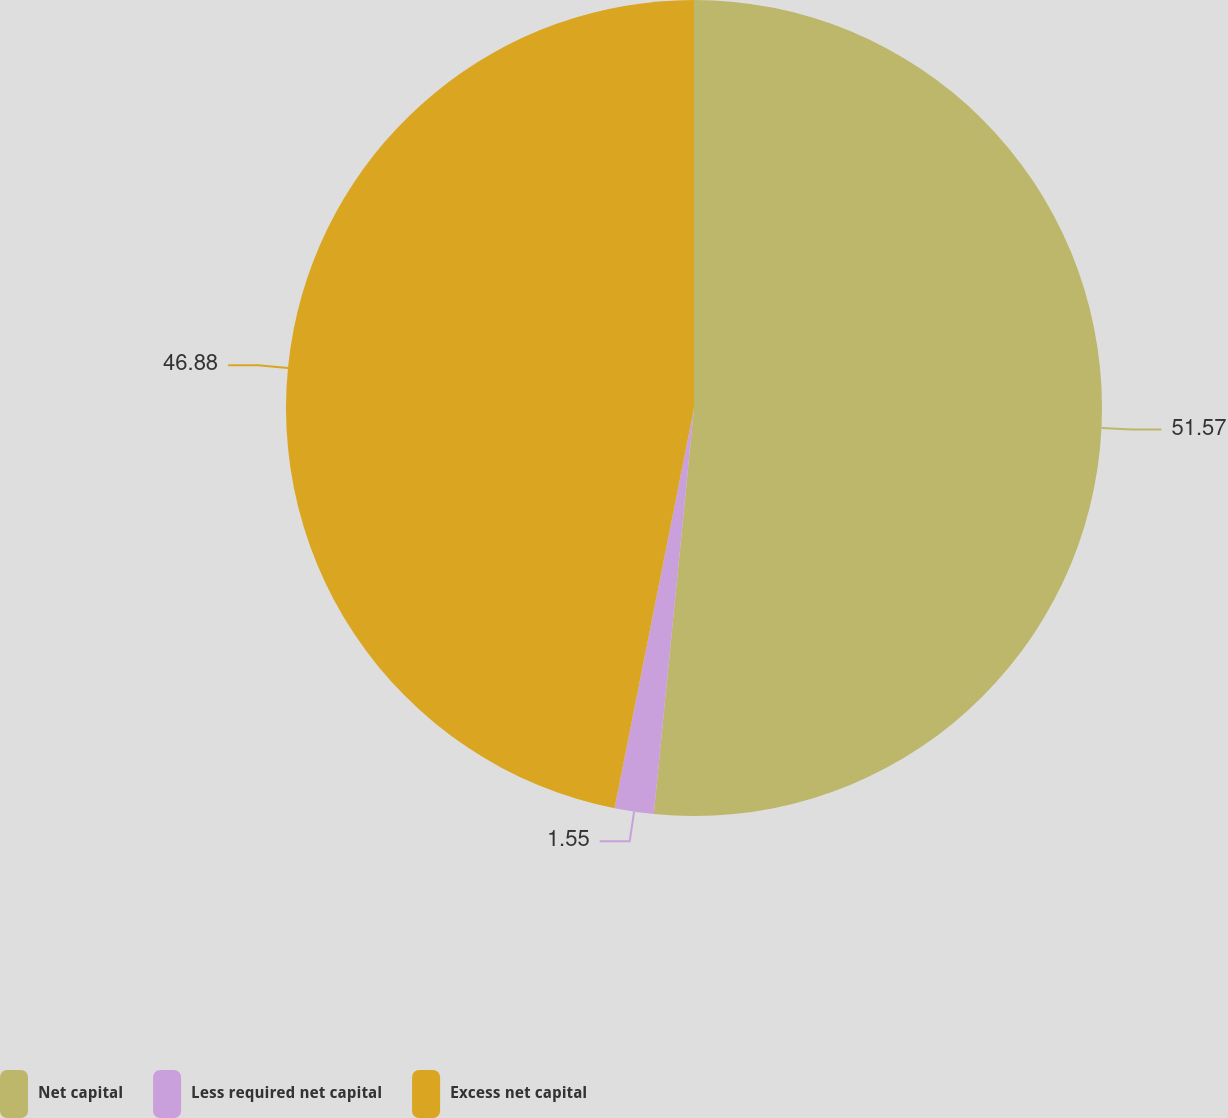Convert chart to OTSL. <chart><loc_0><loc_0><loc_500><loc_500><pie_chart><fcel>Net capital<fcel>Less required net capital<fcel>Excess net capital<nl><fcel>51.57%<fcel>1.55%<fcel>46.88%<nl></chart> 